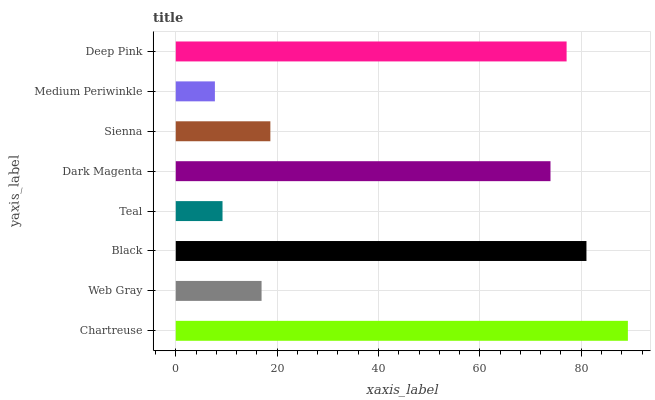Is Medium Periwinkle the minimum?
Answer yes or no. Yes. Is Chartreuse the maximum?
Answer yes or no. Yes. Is Web Gray the minimum?
Answer yes or no. No. Is Web Gray the maximum?
Answer yes or no. No. Is Chartreuse greater than Web Gray?
Answer yes or no. Yes. Is Web Gray less than Chartreuse?
Answer yes or no. Yes. Is Web Gray greater than Chartreuse?
Answer yes or no. No. Is Chartreuse less than Web Gray?
Answer yes or no. No. Is Dark Magenta the high median?
Answer yes or no. Yes. Is Sienna the low median?
Answer yes or no. Yes. Is Teal the high median?
Answer yes or no. No. Is Dark Magenta the low median?
Answer yes or no. No. 